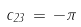<formula> <loc_0><loc_0><loc_500><loc_500>c _ { 2 3 } \, = \, - \pi</formula> 